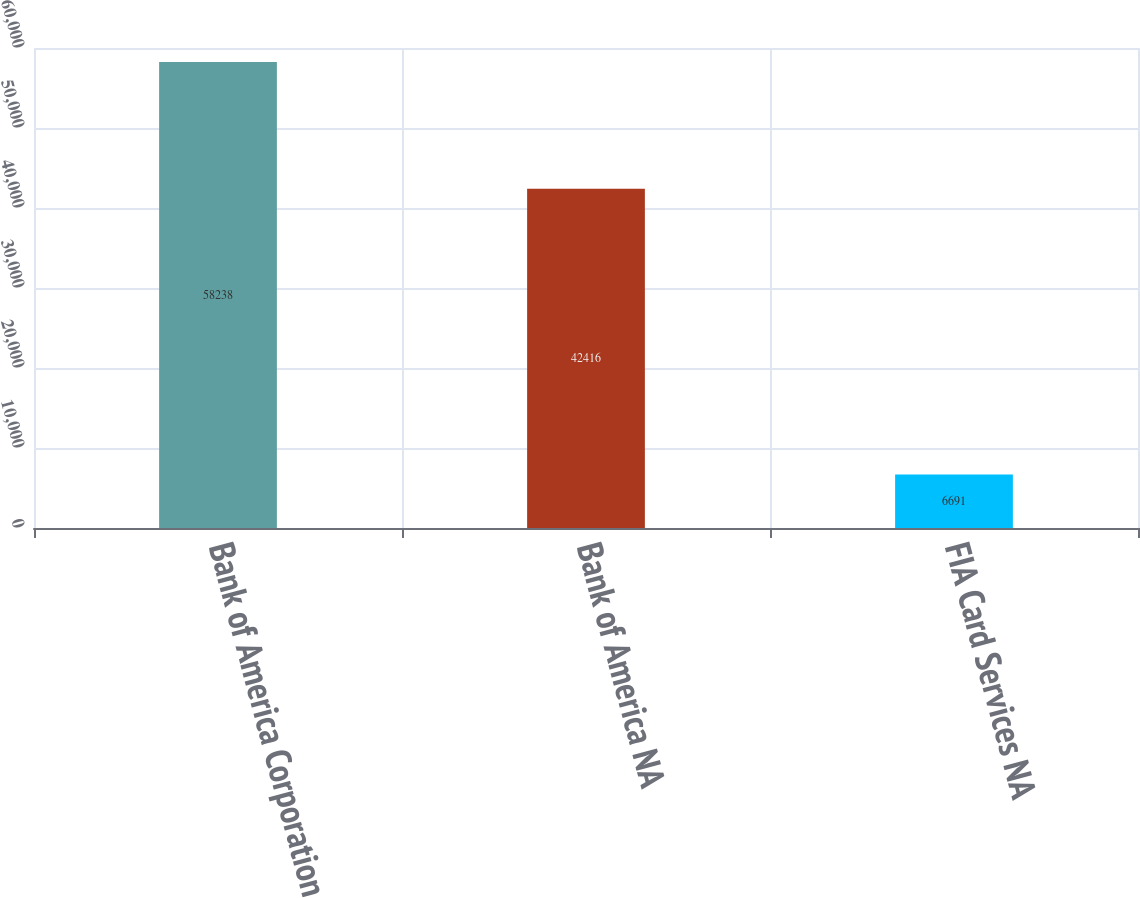<chart> <loc_0><loc_0><loc_500><loc_500><bar_chart><fcel>Bank of America Corporation<fcel>Bank of America NA<fcel>FIA Card Services NA<nl><fcel>58238<fcel>42416<fcel>6691<nl></chart> 